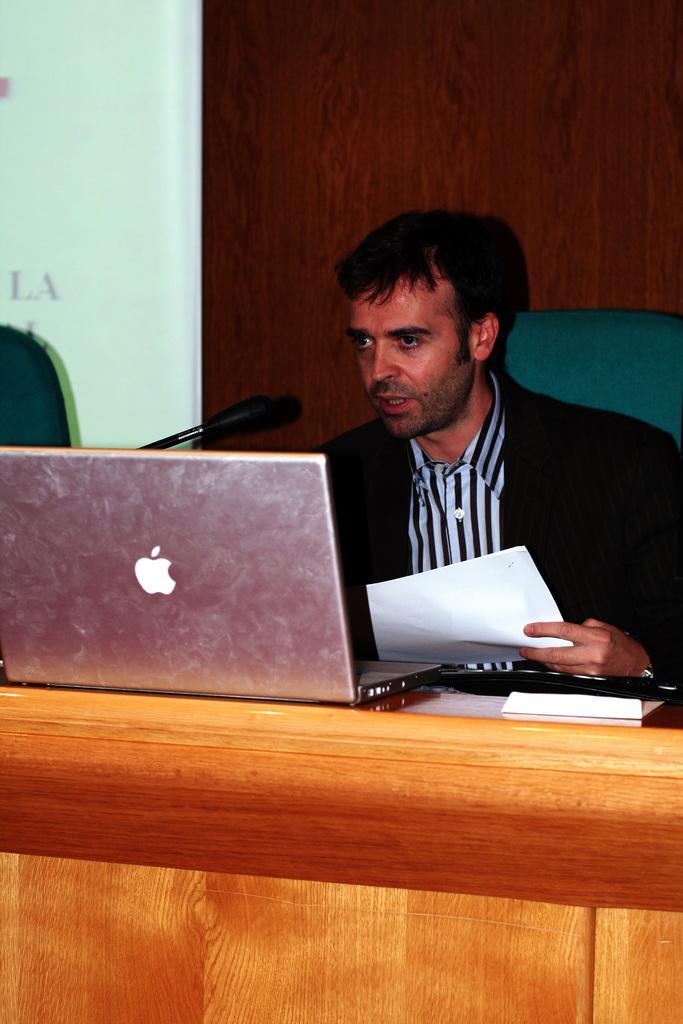In one or two sentences, can you explain what this image depicts? In this image, There is a table which is in yellow color, There is a laptop on that table which is in ash color, There is a man sitting and there is a microphone which is in black color he is holding a paper which is in white color, In the background there is a brown color wall. 